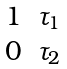<formula> <loc_0><loc_0><loc_500><loc_500>\begin{matrix} 1 & \tau _ { 1 } \\ 0 & \tau _ { 2 } \end{matrix}</formula> 